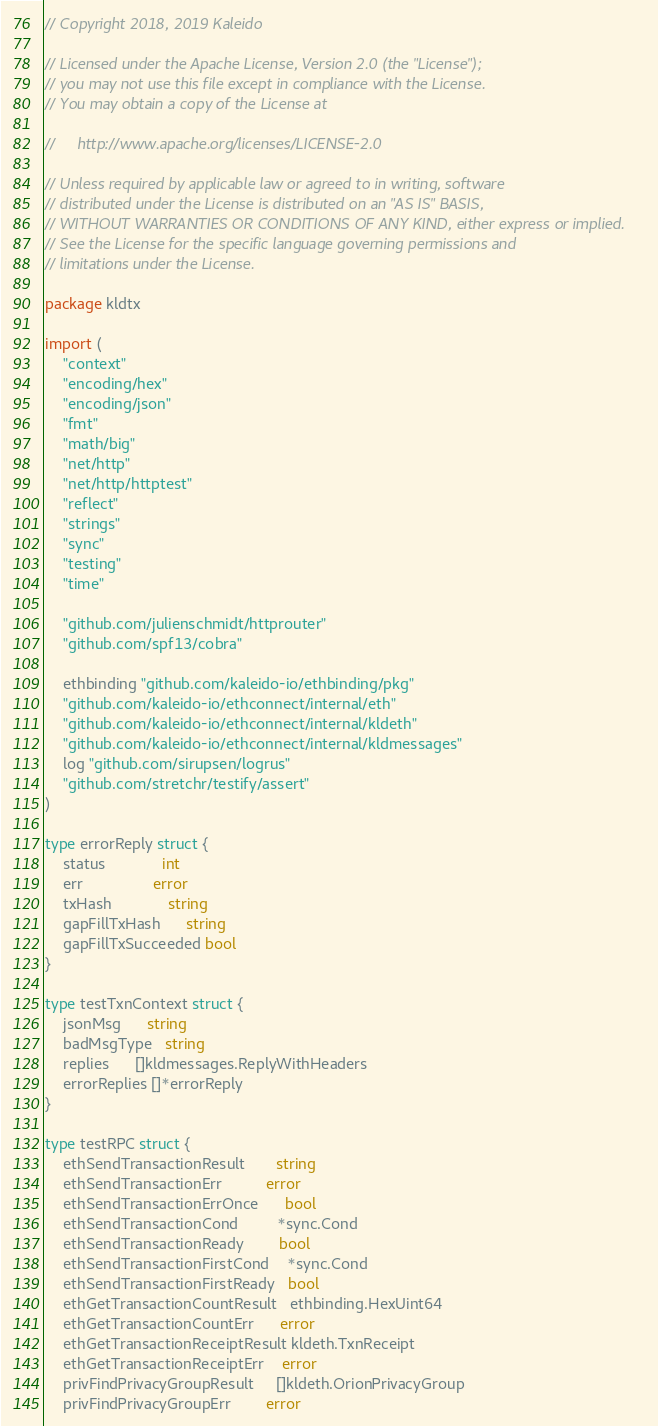Convert code to text. <code><loc_0><loc_0><loc_500><loc_500><_Go_>// Copyright 2018, 2019 Kaleido

// Licensed under the Apache License, Version 2.0 (the "License");
// you may not use this file except in compliance with the License.
// You may obtain a copy of the License at

//     http://www.apache.org/licenses/LICENSE-2.0

// Unless required by applicable law or agreed to in writing, software
// distributed under the License is distributed on an "AS IS" BASIS,
// WITHOUT WARRANTIES OR CONDITIONS OF ANY KIND, either express or implied.
// See the License for the specific language governing permissions and
// limitations under the License.

package kldtx

import (
	"context"
	"encoding/hex"
	"encoding/json"
	"fmt"
	"math/big"
	"net/http"
	"net/http/httptest"
	"reflect"
	"strings"
	"sync"
	"testing"
	"time"

	"github.com/julienschmidt/httprouter"
	"github.com/spf13/cobra"

	ethbinding "github.com/kaleido-io/ethbinding/pkg"
	"github.com/kaleido-io/ethconnect/internal/eth"
	"github.com/kaleido-io/ethconnect/internal/kldeth"
	"github.com/kaleido-io/ethconnect/internal/kldmessages"
	log "github.com/sirupsen/logrus"
	"github.com/stretchr/testify/assert"
)

type errorReply struct {
	status             int
	err                error
	txHash             string
	gapFillTxHash      string
	gapFillTxSucceeded bool
}

type testTxnContext struct {
	jsonMsg      string
	badMsgType   string
	replies      []kldmessages.ReplyWithHeaders
	errorReplies []*errorReply
}

type testRPC struct {
	ethSendTransactionResult       string
	ethSendTransactionErr          error
	ethSendTransactionErrOnce      bool
	ethSendTransactionCond         *sync.Cond
	ethSendTransactionReady        bool
	ethSendTransactionFirstCond    *sync.Cond
	ethSendTransactionFirstReady   bool
	ethGetTransactionCountResult   ethbinding.HexUint64
	ethGetTransactionCountErr      error
	ethGetTransactionReceiptResult kldeth.TxnReceipt
	ethGetTransactionReceiptErr    error
	privFindPrivacyGroupResult     []kldeth.OrionPrivacyGroup
	privFindPrivacyGroupErr        error</code> 